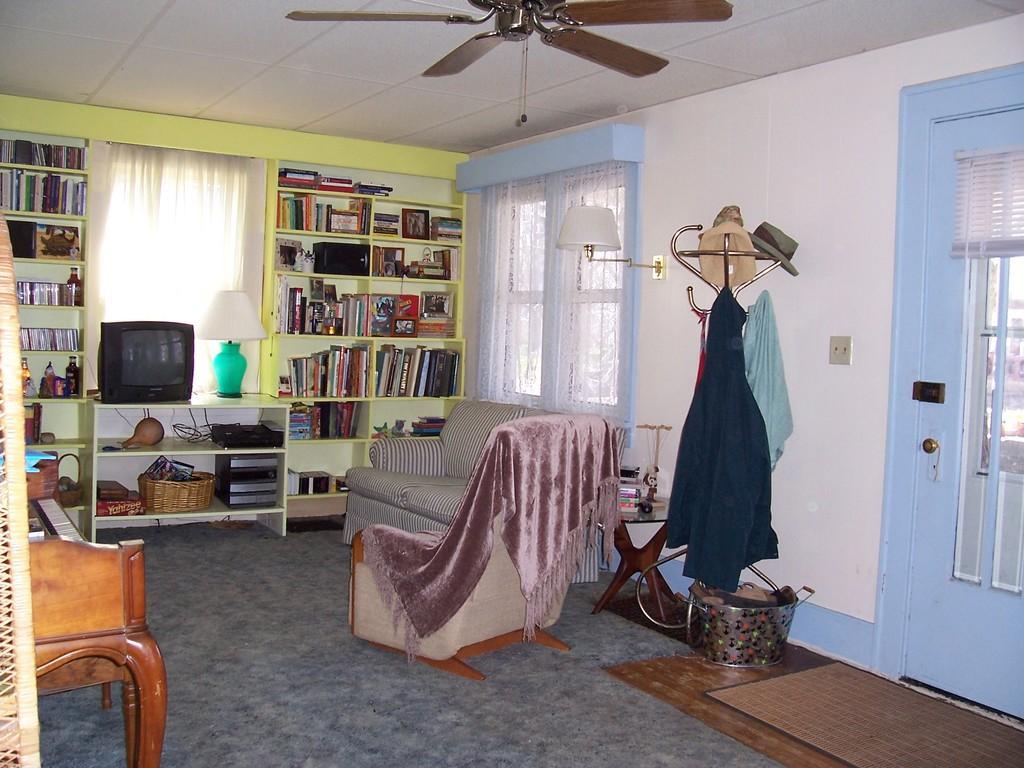Describe this image in one or two sentences. In this image I can see inside view of a room. In the center I can see few sofa chairs. In the background I can see number of books on these shelves. I can also see a television, a lamp, a white colour curtain, a basket and few other things in the background. On the right side of this image I can see a window, one more curtain, few clothes and few hats on a stand and I can also see a blue colour door on the right side. On the top of this image I can see a ceiling fan. Near the window I can see a light. 